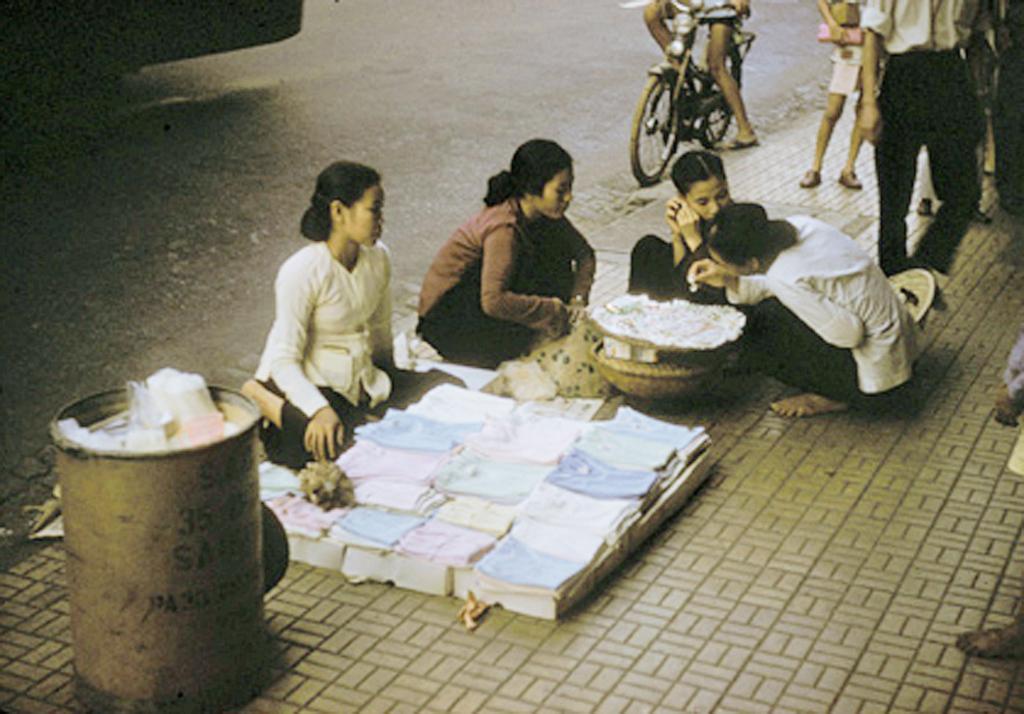Can you describe this image briefly? In this image, we can see persons wearing clothes. There is a person at the top of the image riding a bicycle. There is a basket in the middle of the image. There are some clothes at the bottom of the image. There is a trash bin in the bottom left of the image. 